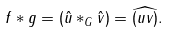Convert formula to latex. <formula><loc_0><loc_0><loc_500><loc_500>f \ast g = ( \hat { u } \ast _ { G } \hat { v } ) = \widehat { ( u v ) } .</formula> 